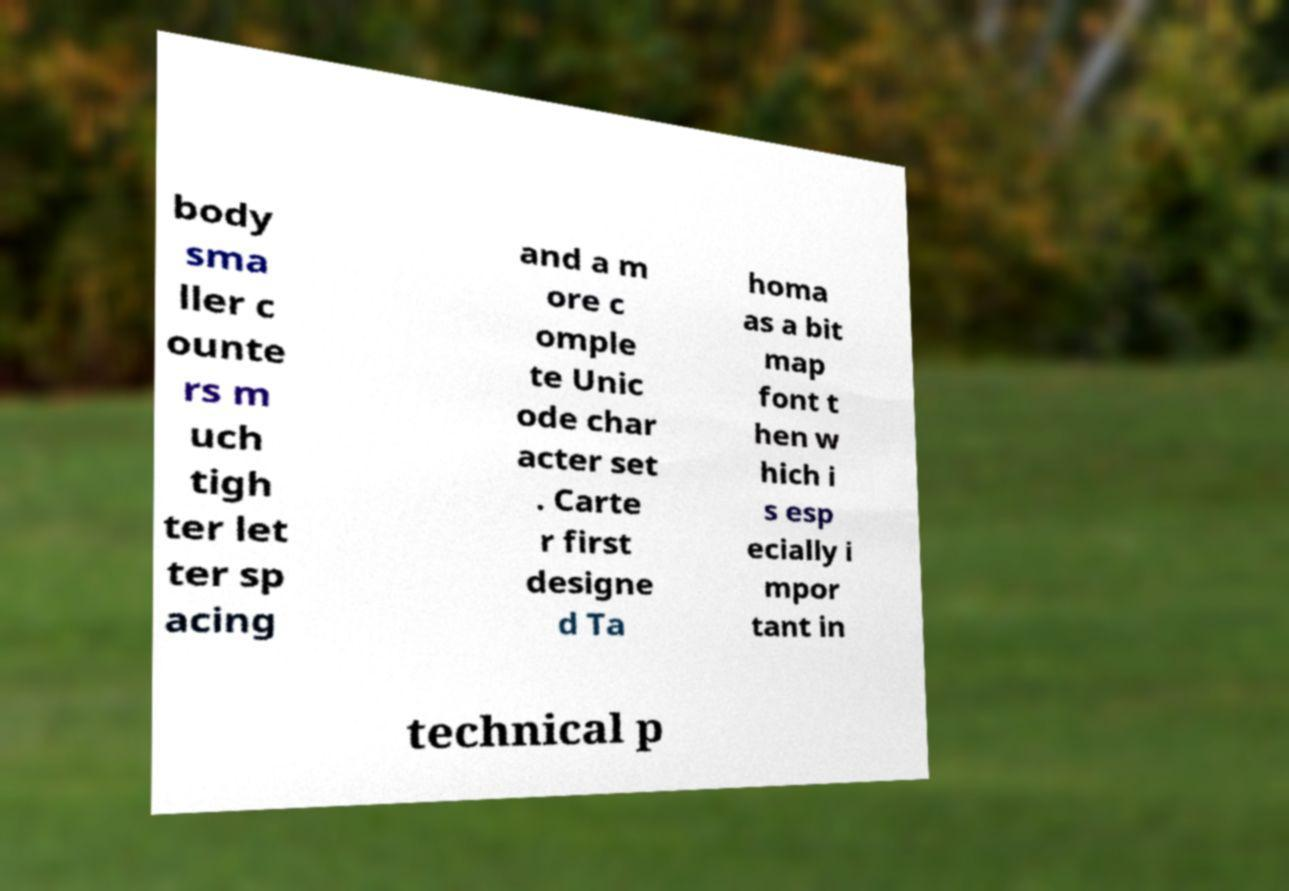Can you read and provide the text displayed in the image?This photo seems to have some interesting text. Can you extract and type it out for me? body sma ller c ounte rs m uch tigh ter let ter sp acing and a m ore c omple te Unic ode char acter set . Carte r first designe d Ta homa as a bit map font t hen w hich i s esp ecially i mpor tant in technical p 